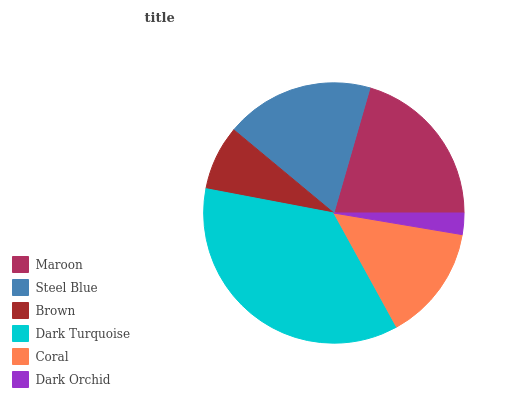Is Dark Orchid the minimum?
Answer yes or no. Yes. Is Dark Turquoise the maximum?
Answer yes or no. Yes. Is Steel Blue the minimum?
Answer yes or no. No. Is Steel Blue the maximum?
Answer yes or no. No. Is Maroon greater than Steel Blue?
Answer yes or no. Yes. Is Steel Blue less than Maroon?
Answer yes or no. Yes. Is Steel Blue greater than Maroon?
Answer yes or no. No. Is Maroon less than Steel Blue?
Answer yes or no. No. Is Steel Blue the high median?
Answer yes or no. Yes. Is Coral the low median?
Answer yes or no. Yes. Is Brown the high median?
Answer yes or no. No. Is Brown the low median?
Answer yes or no. No. 